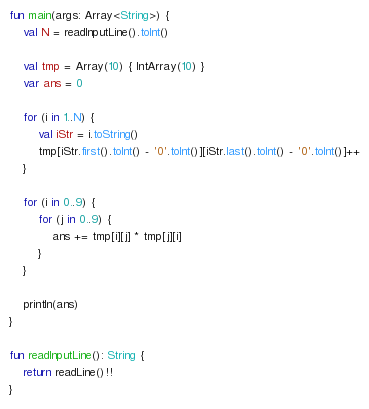Convert code to text. <code><loc_0><loc_0><loc_500><loc_500><_Kotlin_>fun main(args: Array<String>) {
    val N = readInputLine().toInt()

    val tmp = Array(10) { IntArray(10) }
    var ans = 0

    for (i in 1..N) {
        val iStr = i.toString()
        tmp[iStr.first().toInt() - '0'.toInt()][iStr.last().toInt() - '0'.toInt()]++
    }

    for (i in 0..9) {
        for (j in 0..9) {
            ans += tmp[i][j] * tmp[j][i]
        }
    }

    println(ans)
}

fun readInputLine(): String {
    return readLine()!!
}
</code> 